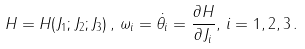<formula> <loc_0><loc_0><loc_500><loc_500>H = H ( J _ { 1 } ; J _ { 2 } ; J _ { 3 } ) \, , \, \omega _ { i } = \dot { \theta _ { i } } = \frac { \partial H } { \partial J _ { i } } , \, i = 1 , 2 , 3 \, .</formula> 